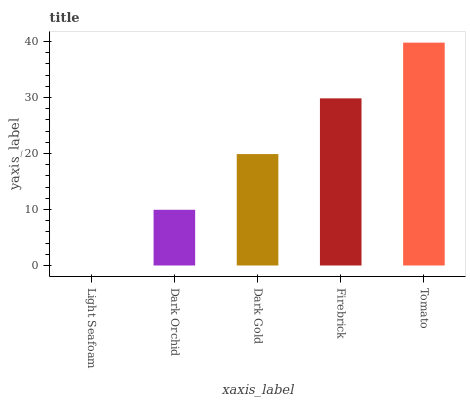Is Light Seafoam the minimum?
Answer yes or no. Yes. Is Tomato the maximum?
Answer yes or no. Yes. Is Dark Orchid the minimum?
Answer yes or no. No. Is Dark Orchid the maximum?
Answer yes or no. No. Is Dark Orchid greater than Light Seafoam?
Answer yes or no. Yes. Is Light Seafoam less than Dark Orchid?
Answer yes or no. Yes. Is Light Seafoam greater than Dark Orchid?
Answer yes or no. No. Is Dark Orchid less than Light Seafoam?
Answer yes or no. No. Is Dark Gold the high median?
Answer yes or no. Yes. Is Dark Gold the low median?
Answer yes or no. Yes. Is Dark Orchid the high median?
Answer yes or no. No. Is Firebrick the low median?
Answer yes or no. No. 